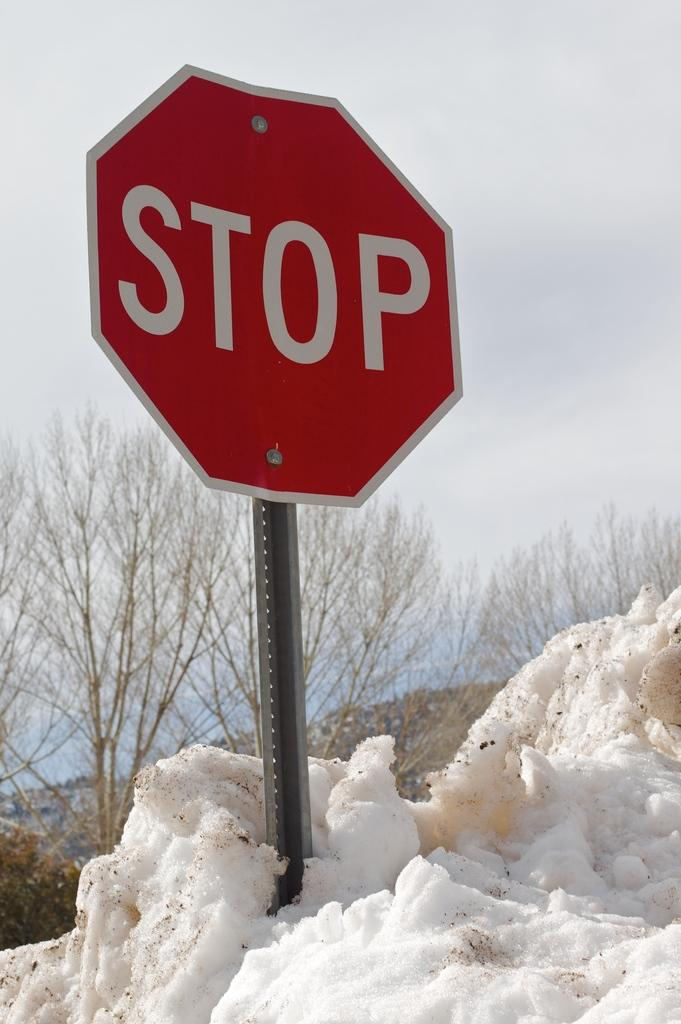What can be seen in the background of the image? There is a sky in the image. What type of vegetation is present in the image? There are trees in the image. What is the unusual element present on the ice? There is a stop board on the ice. Can you see a cat playing with a lock on the ice in the image? No, there is no cat or lock present in the image. 